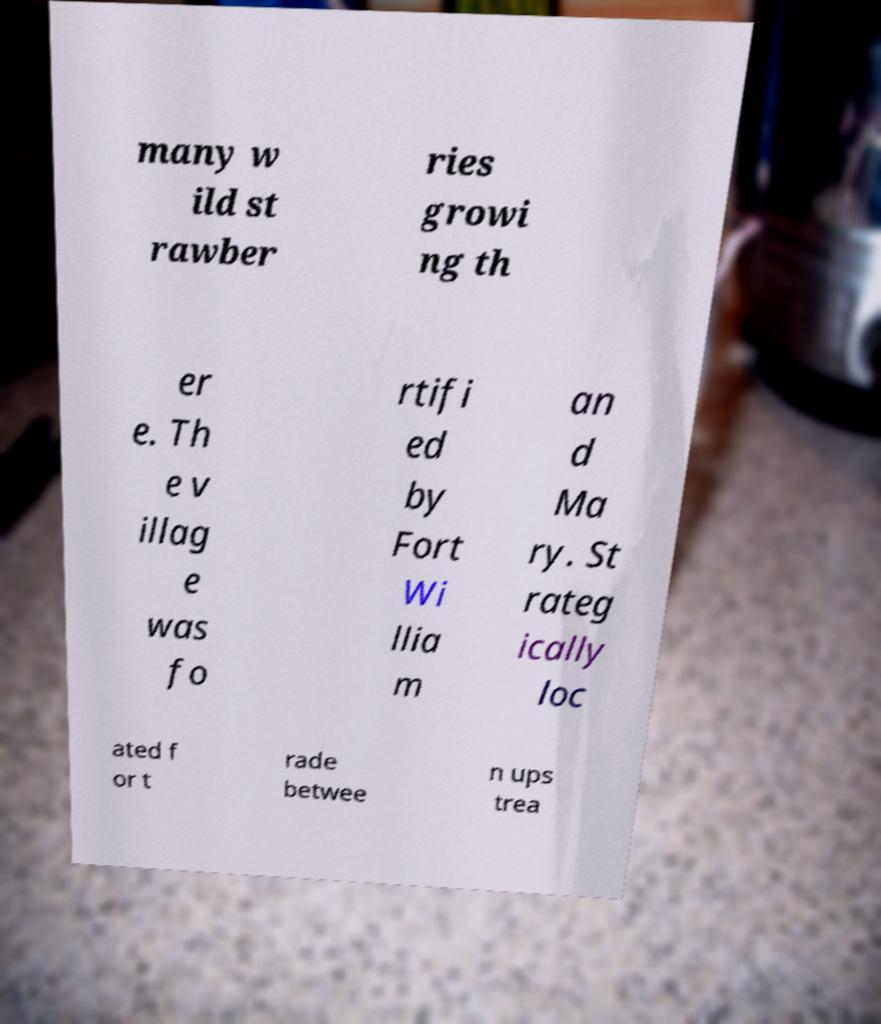Please identify and transcribe the text found in this image. many w ild st rawber ries growi ng th er e. Th e v illag e was fo rtifi ed by Fort Wi llia m an d Ma ry. St rateg ically loc ated f or t rade betwee n ups trea 